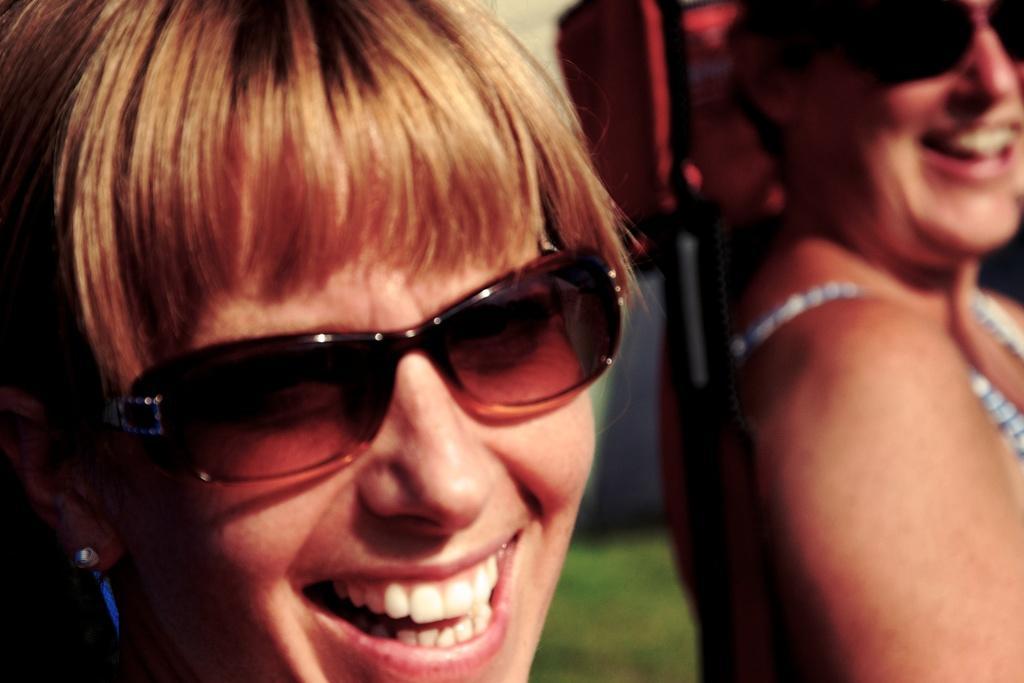Please provide a concise description of this image. In the center of the image there are women. At the bottom of the image there is grass 